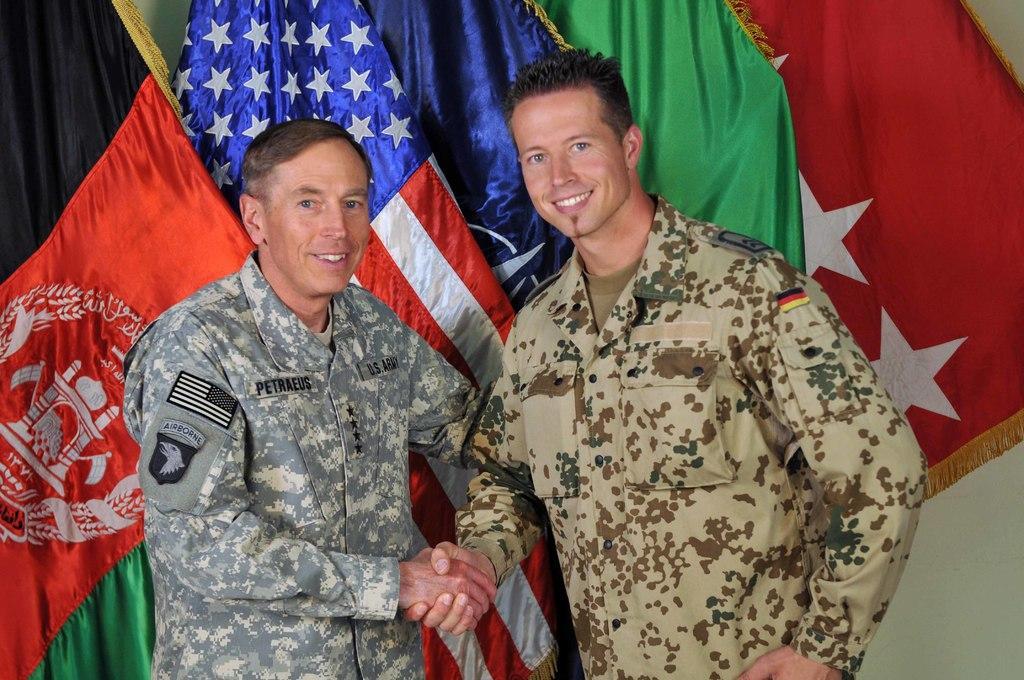How would you summarize this image in a sentence or two? In this picture we can see military soldiers standing in the front, shaking hands and smiling. Behind we can see some flags. 